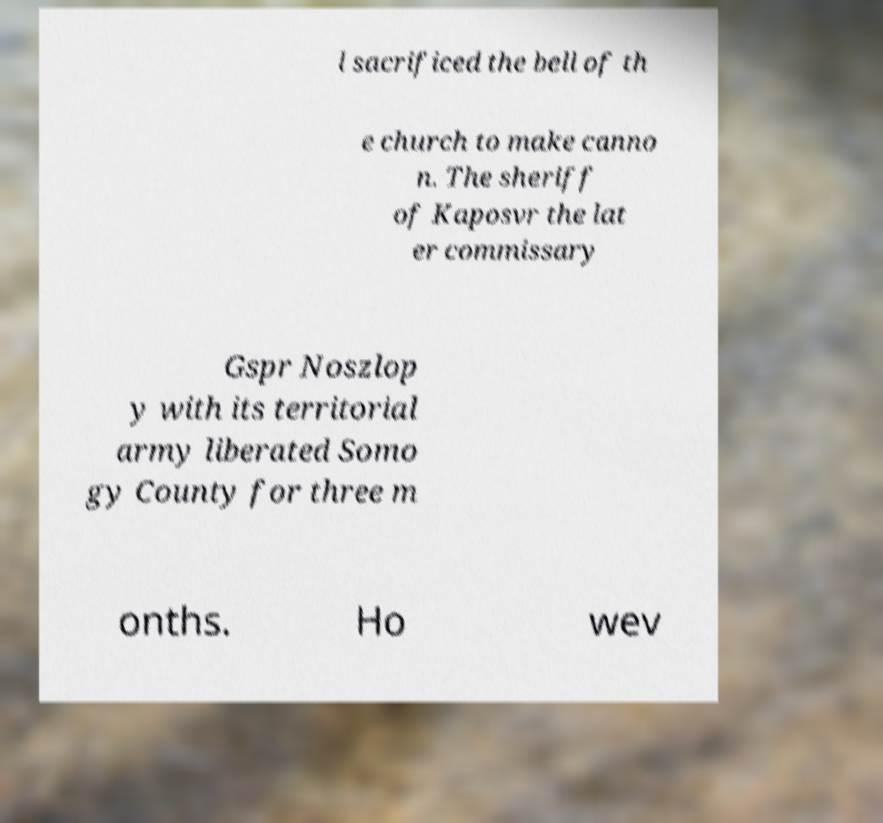Please read and relay the text visible in this image. What does it say? l sacrificed the bell of th e church to make canno n. The sheriff of Kaposvr the lat er commissary Gspr Noszlop y with its territorial army liberated Somo gy County for three m onths. Ho wev 